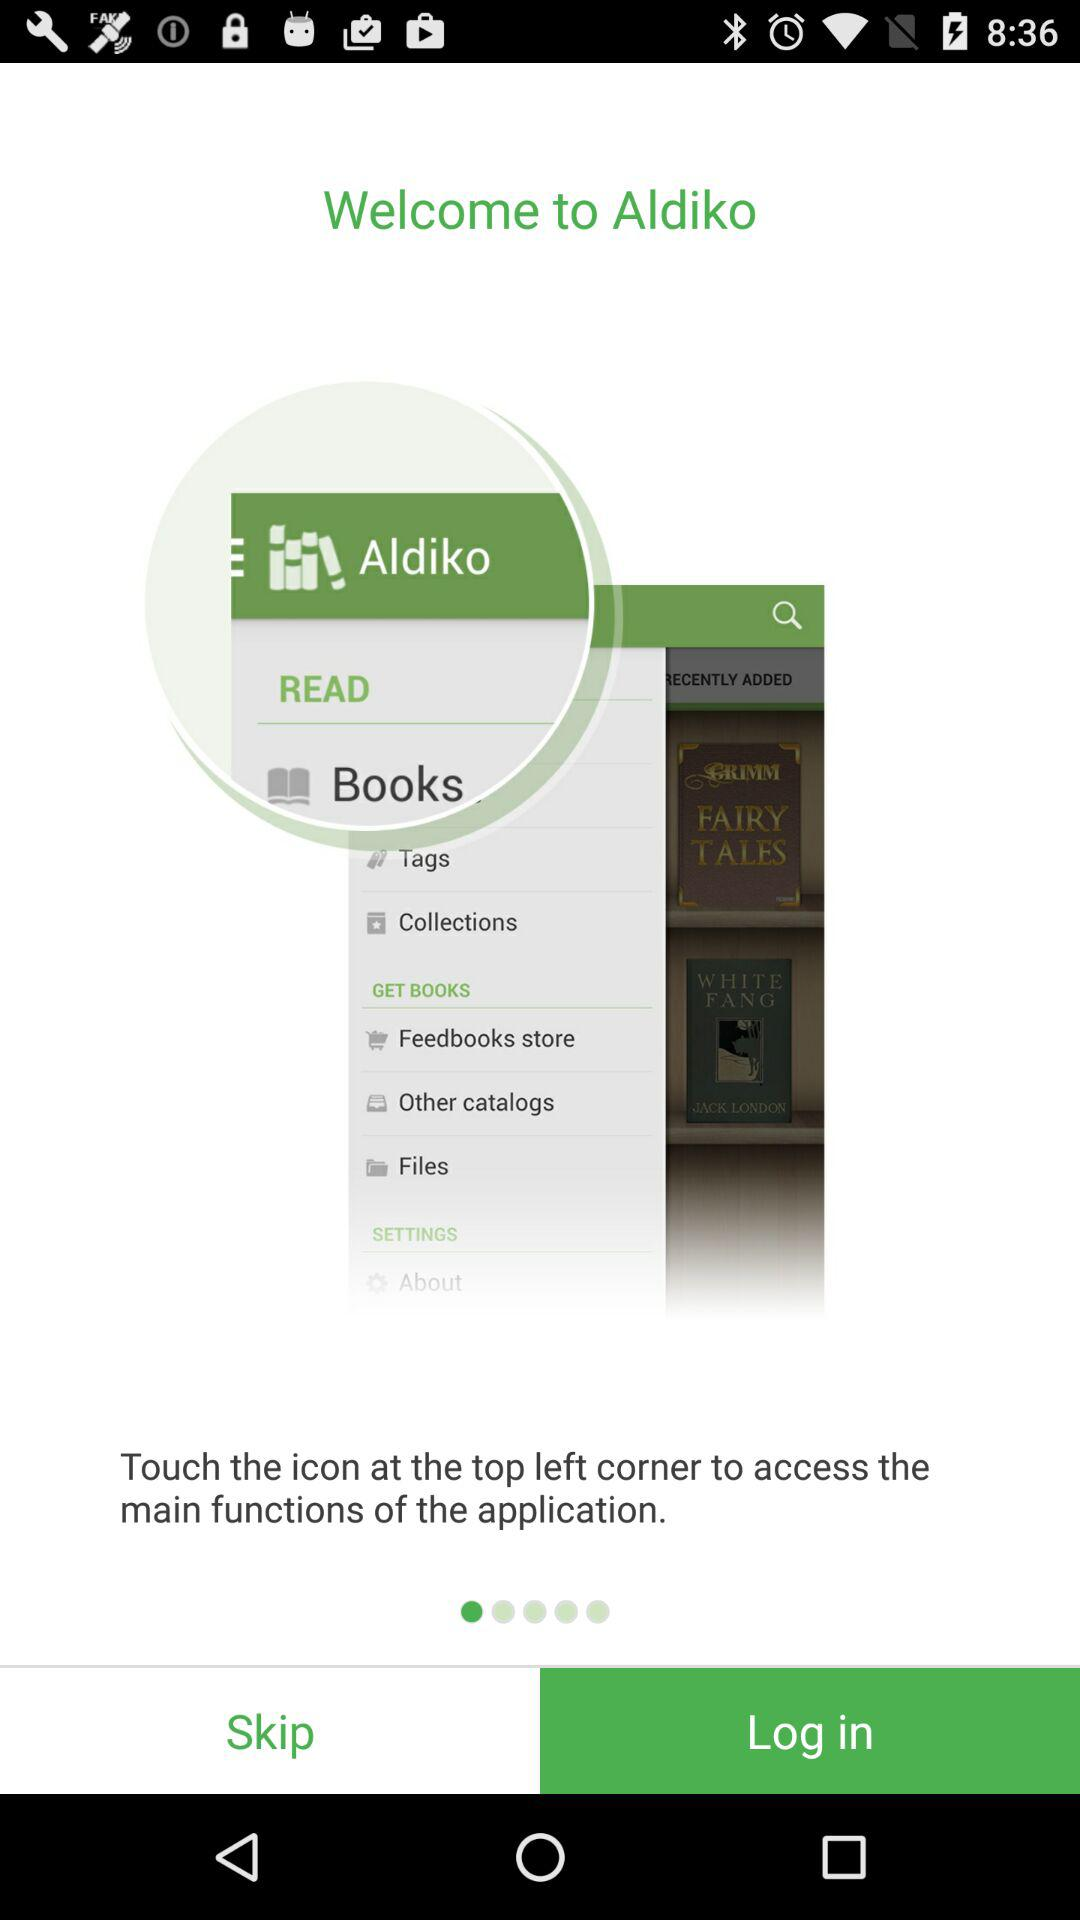Which option is selected for Aldiko?
When the provided information is insufficient, respond with <no answer>. <no answer> 